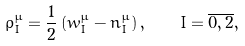Convert formula to latex. <formula><loc_0><loc_0><loc_500><loc_500>\rho _ { I } ^ { \mu } = \frac { 1 } { 2 } \left ( w _ { I } ^ { \mu } - n _ { I } ^ { \mu } \right ) , \quad I = \overline { 0 , 2 } ,</formula> 